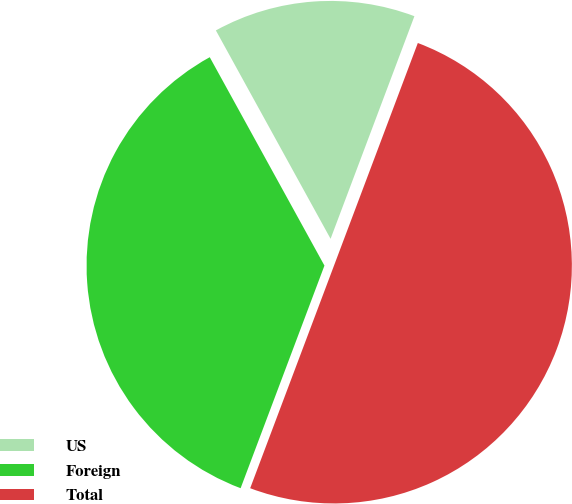Convert chart. <chart><loc_0><loc_0><loc_500><loc_500><pie_chart><fcel>US<fcel>Foreign<fcel>Total<nl><fcel>13.74%<fcel>36.26%<fcel>50.0%<nl></chart> 